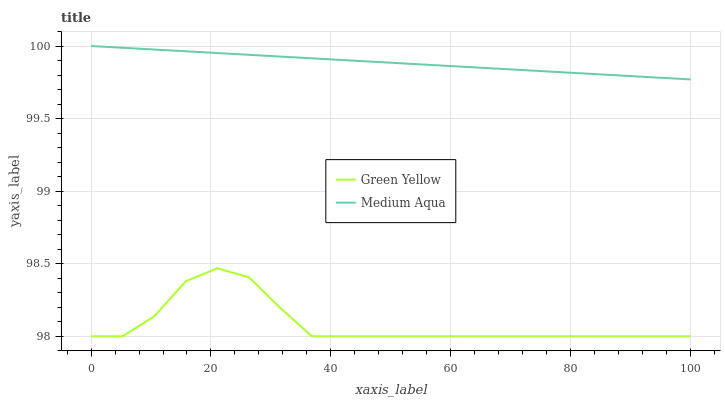Does Medium Aqua have the minimum area under the curve?
Answer yes or no. No. Is Medium Aqua the roughest?
Answer yes or no. No. Does Medium Aqua have the lowest value?
Answer yes or no. No. Is Green Yellow less than Medium Aqua?
Answer yes or no. Yes. Is Medium Aqua greater than Green Yellow?
Answer yes or no. Yes. Does Green Yellow intersect Medium Aqua?
Answer yes or no. No. 